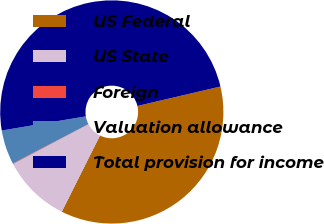<chart> <loc_0><loc_0><loc_500><loc_500><pie_chart><fcel>US Federal<fcel>US State<fcel>Foreign<fcel>Valuation allowance<fcel>Total provision for income<nl><fcel>36.06%<fcel>9.87%<fcel>0.09%<fcel>4.98%<fcel>49.0%<nl></chart> 